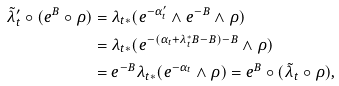Convert formula to latex. <formula><loc_0><loc_0><loc_500><loc_500>\tilde { \lambda } _ { t } ^ { \prime } \circ ( e ^ { B } \circ \rho ) & = \lambda _ { t * } ( e ^ { - \alpha ^ { \prime } _ { t } } \wedge e ^ { - B } \wedge \rho ) \\ & = \lambda _ { t * } ( e ^ { - ( \alpha _ { t } + \lambda _ { t } ^ { * } B - B ) - B } \wedge \rho ) \\ & = e ^ { - B } \lambda _ { t * } ( e ^ { - \alpha _ { t } } \wedge \rho ) = e ^ { B } \circ ( \tilde { \lambda } _ { t } \circ \rho ) ,</formula> 